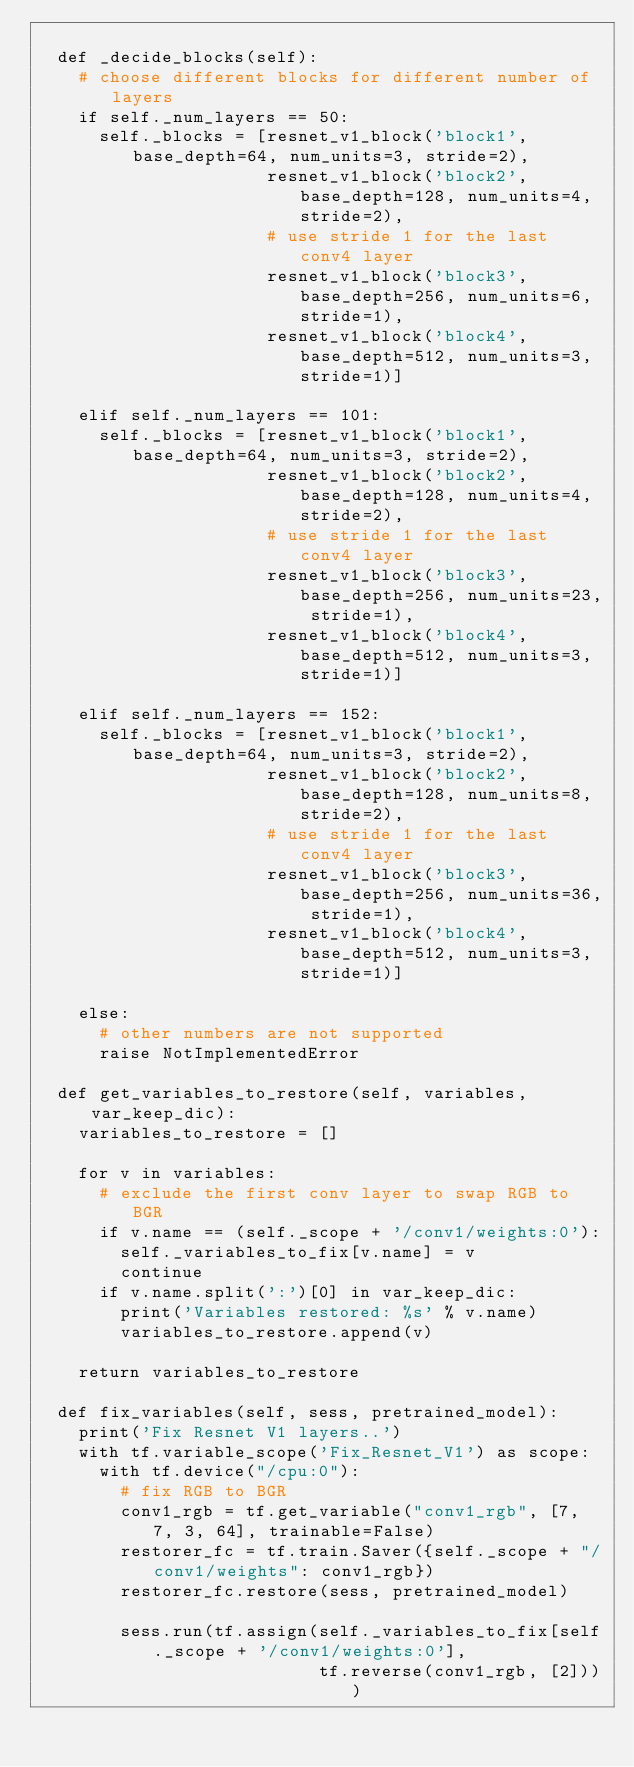Convert code to text. <code><loc_0><loc_0><loc_500><loc_500><_Python_>
  def _decide_blocks(self):
    # choose different blocks for different number of layers
    if self._num_layers == 50:
      self._blocks = [resnet_v1_block('block1', base_depth=64, num_units=3, stride=2),
                      resnet_v1_block('block2', base_depth=128, num_units=4, stride=2),
                      # use stride 1 for the last conv4 layer
                      resnet_v1_block('block3', base_depth=256, num_units=6, stride=1),
                      resnet_v1_block('block4', base_depth=512, num_units=3, stride=1)]

    elif self._num_layers == 101:
      self._blocks = [resnet_v1_block('block1', base_depth=64, num_units=3, stride=2),
                      resnet_v1_block('block2', base_depth=128, num_units=4, stride=2),
                      # use stride 1 for the last conv4 layer
                      resnet_v1_block('block3', base_depth=256, num_units=23, stride=1),
                      resnet_v1_block('block4', base_depth=512, num_units=3, stride=1)]

    elif self._num_layers == 152:
      self._blocks = [resnet_v1_block('block1', base_depth=64, num_units=3, stride=2),
                      resnet_v1_block('block2', base_depth=128, num_units=8, stride=2),
                      # use stride 1 for the last conv4 layer
                      resnet_v1_block('block3', base_depth=256, num_units=36, stride=1),
                      resnet_v1_block('block4', base_depth=512, num_units=3, stride=1)]

    else:
      # other numbers are not supported
      raise NotImplementedError

  def get_variables_to_restore(self, variables, var_keep_dic):
    variables_to_restore = []

    for v in variables:
      # exclude the first conv layer to swap RGB to BGR
      if v.name == (self._scope + '/conv1/weights:0'):
        self._variables_to_fix[v.name] = v
        continue
      if v.name.split(':')[0] in var_keep_dic:
        print('Variables restored: %s' % v.name)
        variables_to_restore.append(v)

    return variables_to_restore

  def fix_variables(self, sess, pretrained_model):
    print('Fix Resnet V1 layers..')
    with tf.variable_scope('Fix_Resnet_V1') as scope:
      with tf.device("/cpu:0"):
        # fix RGB to BGR
        conv1_rgb = tf.get_variable("conv1_rgb", [7, 7, 3, 64], trainable=False)
        restorer_fc = tf.train.Saver({self._scope + "/conv1/weights": conv1_rgb})
        restorer_fc.restore(sess, pretrained_model)

        sess.run(tf.assign(self._variables_to_fix[self._scope + '/conv1/weights:0'], 
                           tf.reverse(conv1_rgb, [2])))
</code> 